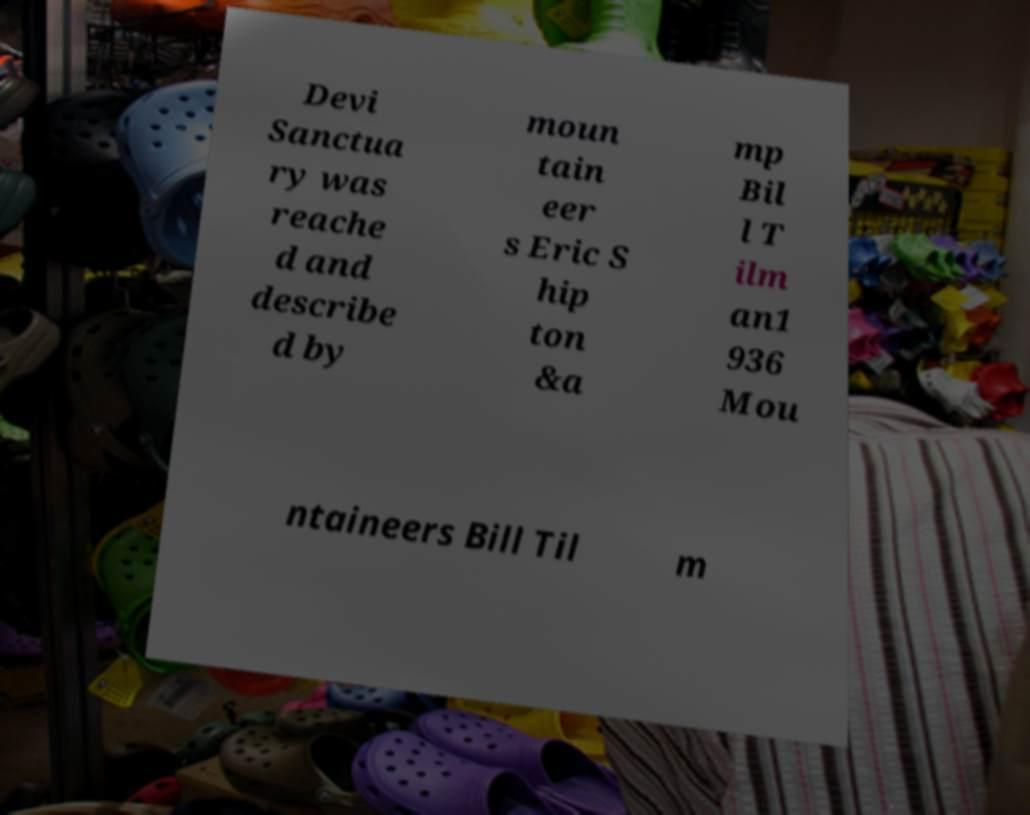Please identify and transcribe the text found in this image. Devi Sanctua ry was reache d and describe d by moun tain eer s Eric S hip ton &a mp Bil l T ilm an1 936 Mou ntaineers Bill Til m 